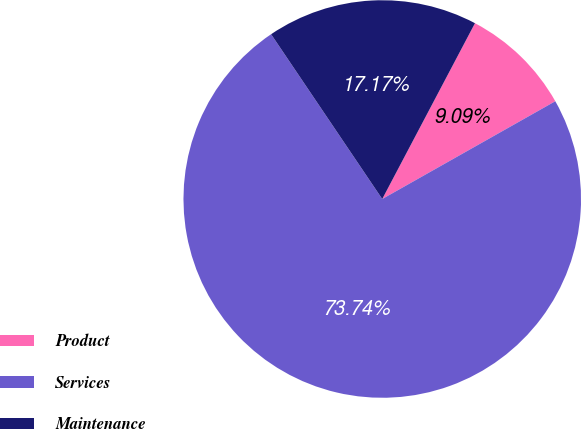Convert chart. <chart><loc_0><loc_0><loc_500><loc_500><pie_chart><fcel>Product<fcel>Services<fcel>Maintenance<nl><fcel>9.09%<fcel>73.74%<fcel>17.17%<nl></chart> 